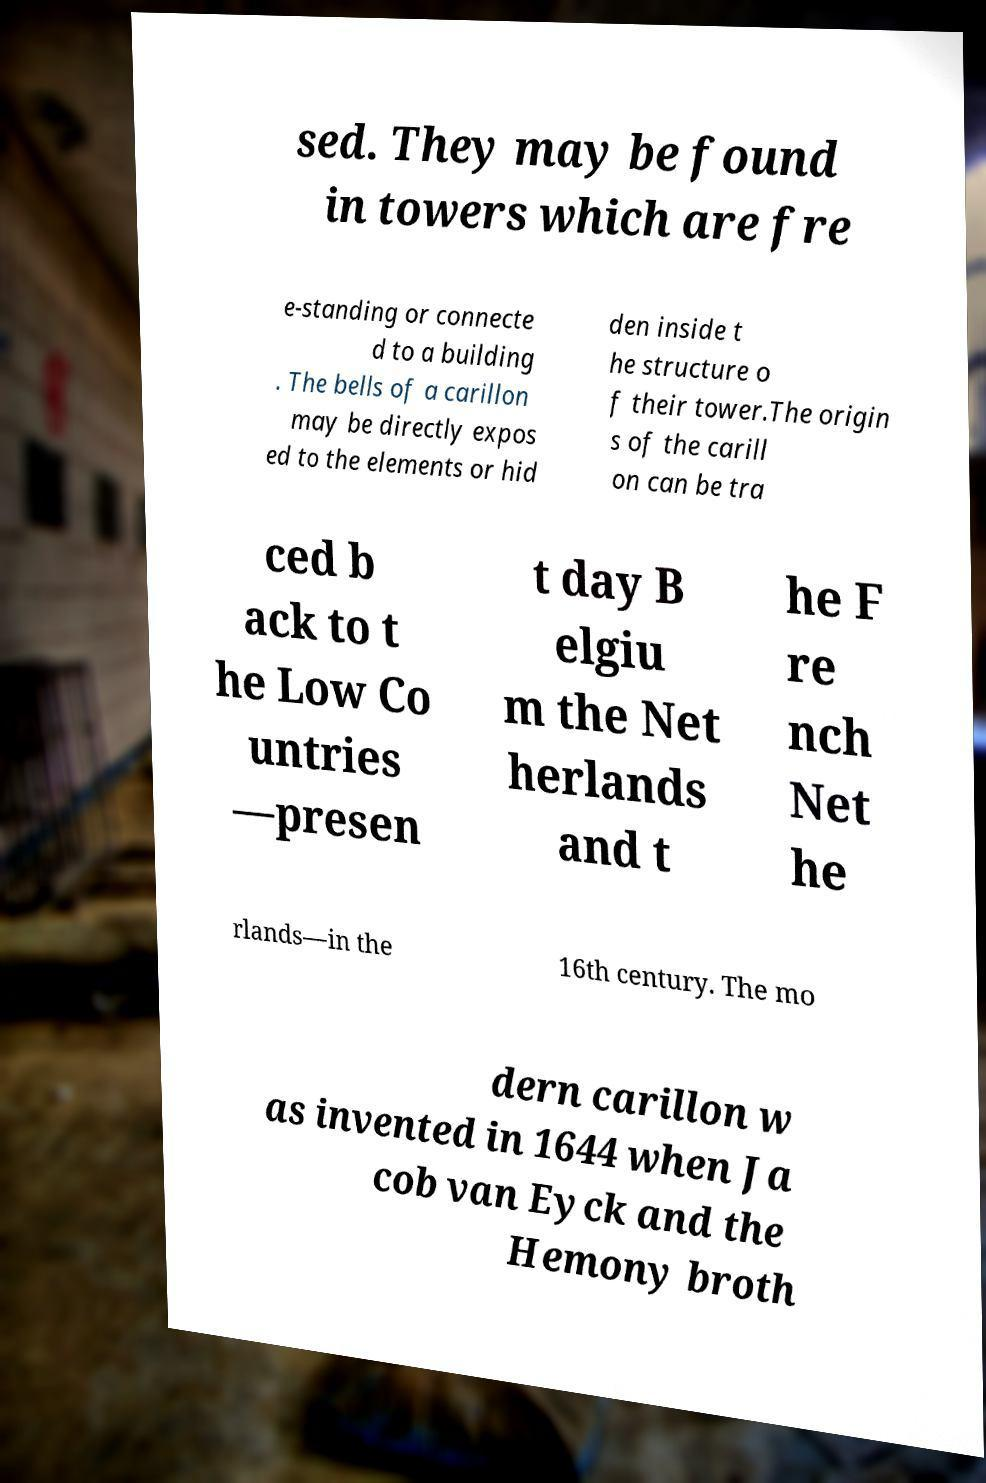There's text embedded in this image that I need extracted. Can you transcribe it verbatim? sed. They may be found in towers which are fre e-standing or connecte d to a building . The bells of a carillon may be directly expos ed to the elements or hid den inside t he structure o f their tower.The origin s of the carill on can be tra ced b ack to t he Low Co untries —presen t day B elgiu m the Net herlands and t he F re nch Net he rlands—in the 16th century. The mo dern carillon w as invented in 1644 when Ja cob van Eyck and the Hemony broth 